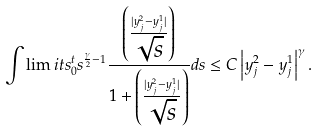Convert formula to latex. <formula><loc_0><loc_0><loc_500><loc_500>\int \lim i t s _ { 0 } ^ { t } s ^ { \frac { \gamma } { 2 } - 1 } \frac { \left ( \frac { | y ^ { 2 } _ { j } - y ^ { 1 } _ { j } | } { \sqrt { s } } \right ) } { 1 + \left ( \frac { | y ^ { 2 } _ { j } - y ^ { 1 } _ { j } | } { \sqrt { s } } \right ) } d s \leq C \left | y ^ { 2 } _ { j } - y ^ { 1 } _ { j } \right | ^ { \gamma } .</formula> 